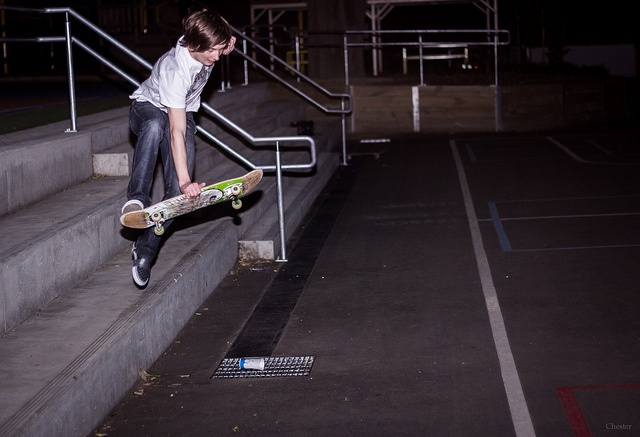Describe the objects in this image and their specific colors. I can see people in black, lavender, and gray tones and skateboard in black, darkgray, and gray tones in this image. 